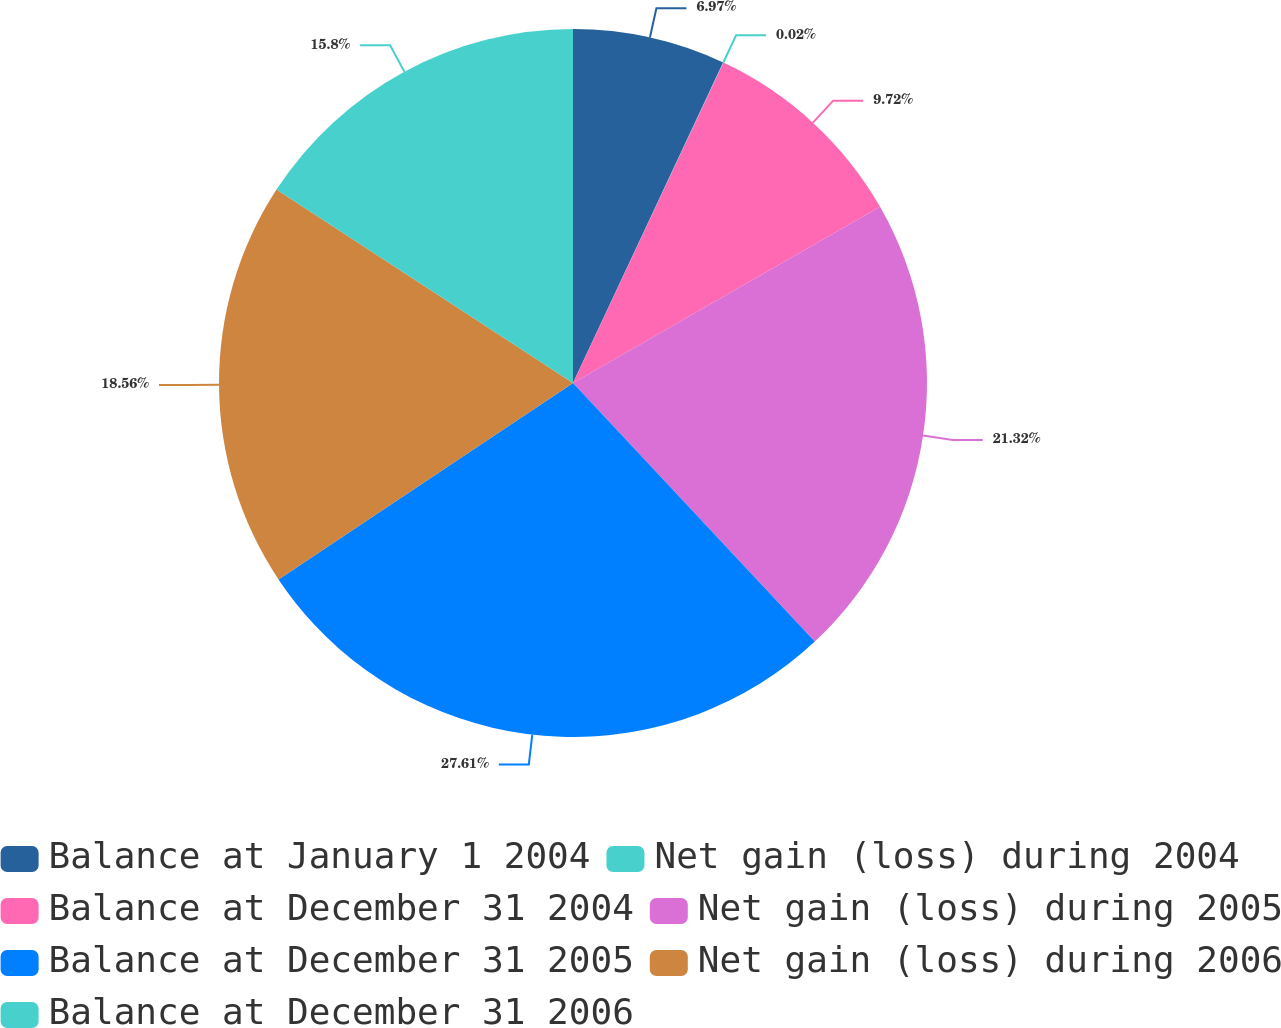<chart> <loc_0><loc_0><loc_500><loc_500><pie_chart><fcel>Balance at January 1 2004<fcel>Net gain (loss) during 2004<fcel>Balance at December 31 2004<fcel>Net gain (loss) during 2005<fcel>Balance at December 31 2005<fcel>Net gain (loss) during 2006<fcel>Balance at December 31 2006<nl><fcel>6.97%<fcel>0.02%<fcel>9.72%<fcel>21.32%<fcel>27.6%<fcel>18.56%<fcel>15.8%<nl></chart> 